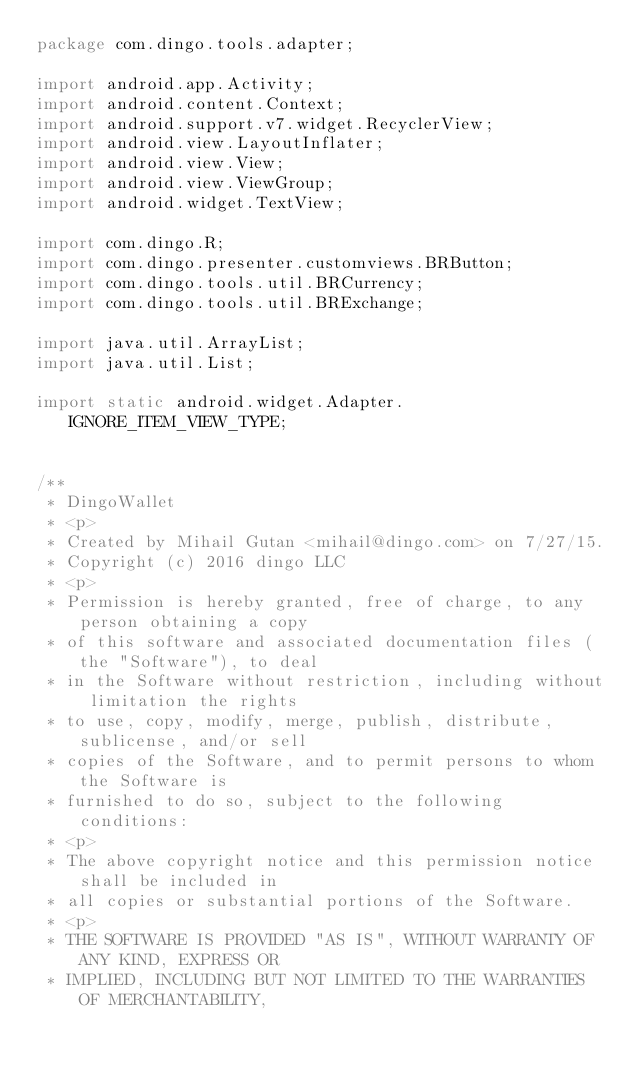Convert code to text. <code><loc_0><loc_0><loc_500><loc_500><_Java_>package com.dingo.tools.adapter;

import android.app.Activity;
import android.content.Context;
import android.support.v7.widget.RecyclerView;
import android.view.LayoutInflater;
import android.view.View;
import android.view.ViewGroup;
import android.widget.TextView;

import com.dingo.R;
import com.dingo.presenter.customviews.BRButton;
import com.dingo.tools.util.BRCurrency;
import com.dingo.tools.util.BRExchange;

import java.util.ArrayList;
import java.util.List;

import static android.widget.Adapter.IGNORE_ITEM_VIEW_TYPE;


/**
 * DingoWallet
 * <p>
 * Created by Mihail Gutan <mihail@dingo.com> on 7/27/15.
 * Copyright (c) 2016 dingo LLC
 * <p>
 * Permission is hereby granted, free of charge, to any person obtaining a copy
 * of this software and associated documentation files (the "Software"), to deal
 * in the Software without restriction, including without limitation the rights
 * to use, copy, modify, merge, publish, distribute, sublicense, and/or sell
 * copies of the Software, and to permit persons to whom the Software is
 * furnished to do so, subject to the following conditions:
 * <p>
 * The above copyright notice and this permission notice shall be included in
 * all copies or substantial portions of the Software.
 * <p>
 * THE SOFTWARE IS PROVIDED "AS IS", WITHOUT WARRANTY OF ANY KIND, EXPRESS OR
 * IMPLIED, INCLUDING BUT NOT LIMITED TO THE WARRANTIES OF MERCHANTABILITY,</code> 